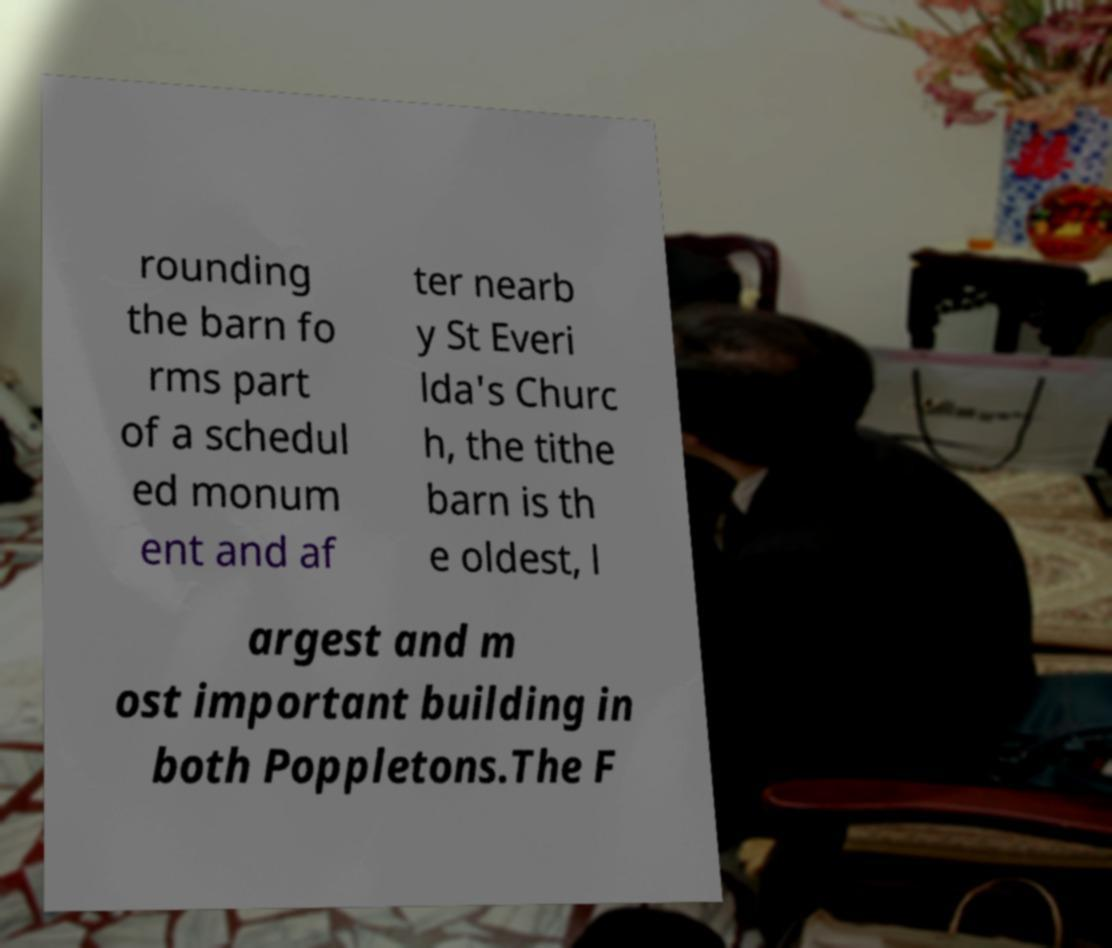What messages or text are displayed in this image? I need them in a readable, typed format. rounding the barn fo rms part of a schedul ed monum ent and af ter nearb y St Everi lda's Churc h, the tithe barn is th e oldest, l argest and m ost important building in both Poppletons.The F 